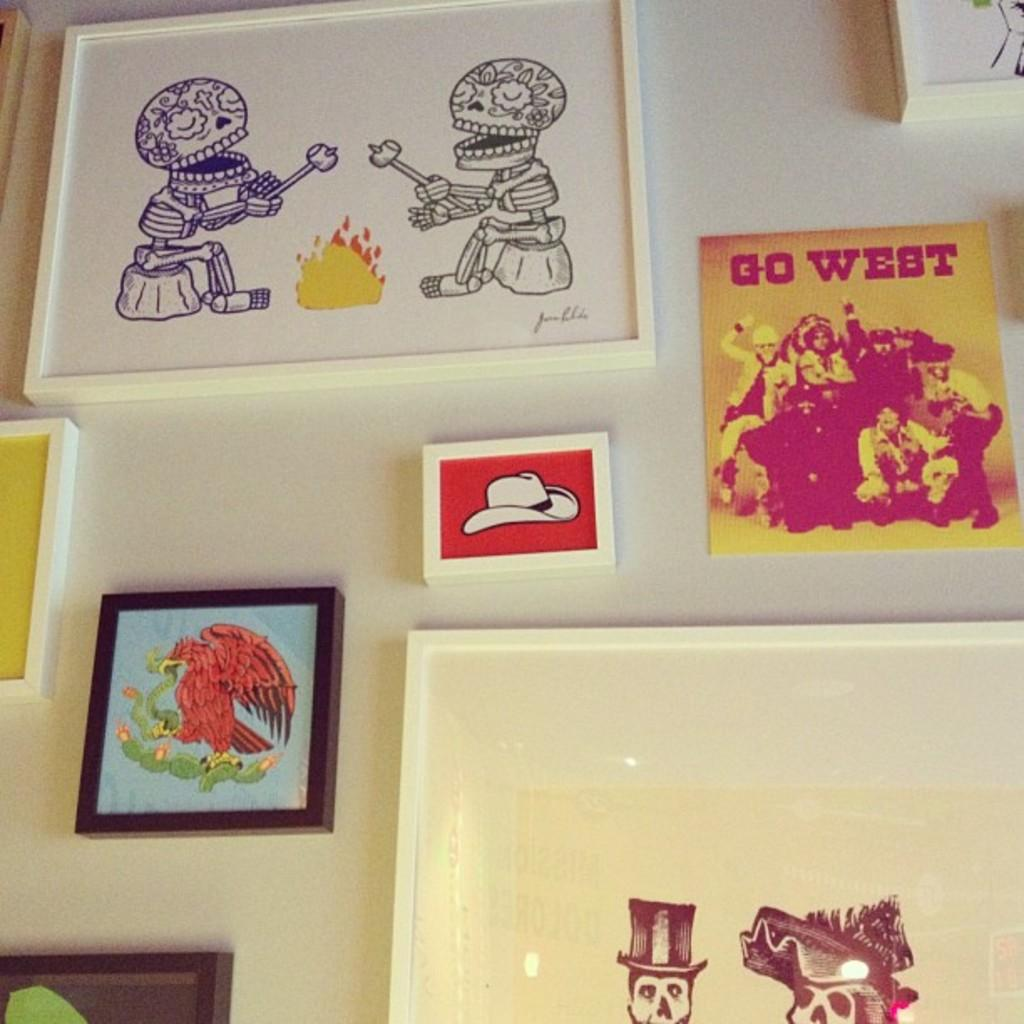<image>
Provide a brief description of the given image. Several pictures, one of which has the words Go West in red. 